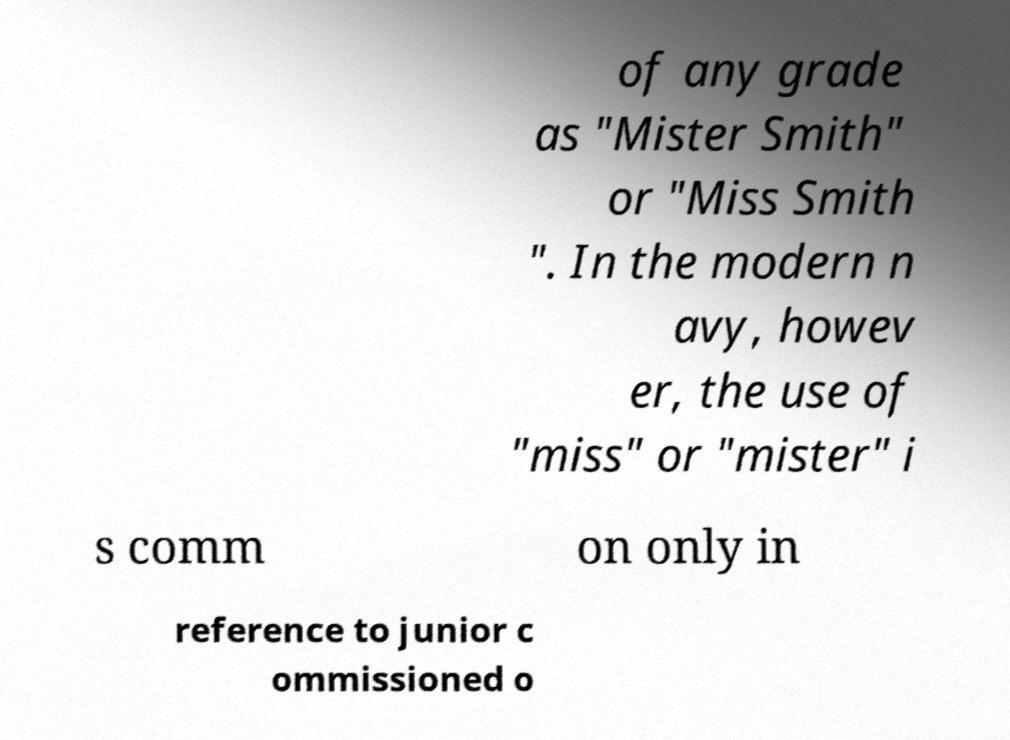I need the written content from this picture converted into text. Can you do that? of any grade as "Mister Smith" or "Miss Smith ". In the modern n avy, howev er, the use of "miss" or "mister" i s comm on only in reference to junior c ommissioned o 